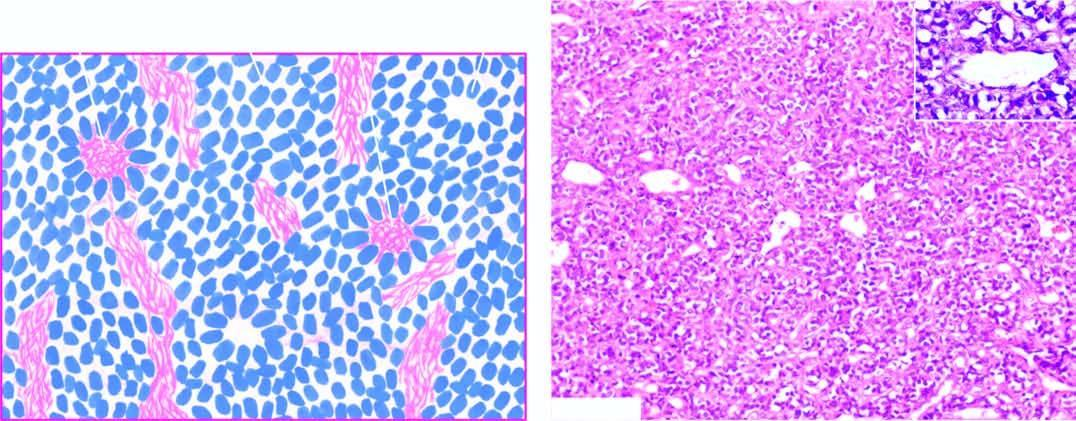does neuroblastoma show small, round to oval cells forming irregular sheets separated by fibrovascular stroma?
Answer the question using a single word or phrase. Yes 